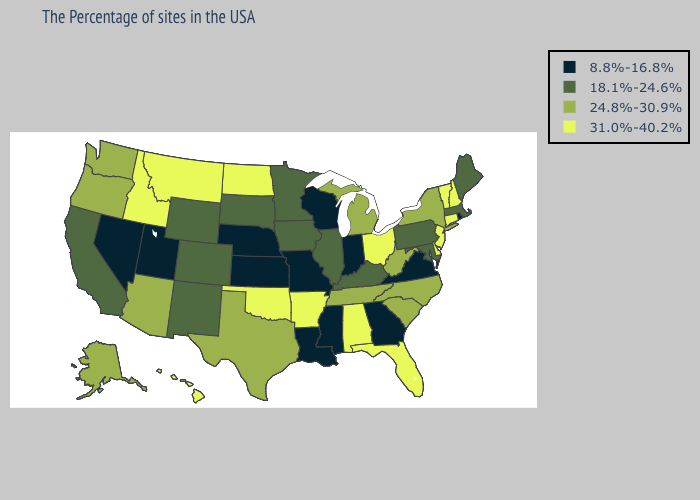What is the value of Oklahoma?
Concise answer only. 31.0%-40.2%. Does Iowa have the lowest value in the MidWest?
Be succinct. No. Name the states that have a value in the range 18.1%-24.6%?
Quick response, please. Maine, Massachusetts, Maryland, Pennsylvania, Kentucky, Illinois, Minnesota, Iowa, South Dakota, Wyoming, Colorado, New Mexico, California. Among the states that border Indiana , does Illinois have the highest value?
Concise answer only. No. What is the value of Michigan?
Short answer required. 24.8%-30.9%. Name the states that have a value in the range 24.8%-30.9%?
Give a very brief answer. New York, North Carolina, South Carolina, West Virginia, Michigan, Tennessee, Texas, Arizona, Washington, Oregon, Alaska. Name the states that have a value in the range 24.8%-30.9%?
Answer briefly. New York, North Carolina, South Carolina, West Virginia, Michigan, Tennessee, Texas, Arizona, Washington, Oregon, Alaska. Which states have the lowest value in the South?
Short answer required. Virginia, Georgia, Mississippi, Louisiana. Which states have the lowest value in the USA?
Short answer required. Rhode Island, Virginia, Georgia, Indiana, Wisconsin, Mississippi, Louisiana, Missouri, Kansas, Nebraska, Utah, Nevada. Does Pennsylvania have the highest value in the Northeast?
Answer briefly. No. What is the lowest value in the South?
Answer briefly. 8.8%-16.8%. Among the states that border Oklahoma , does Arkansas have the highest value?
Keep it brief. Yes. What is the value of Wisconsin?
Give a very brief answer. 8.8%-16.8%. Among the states that border Washington , does Idaho have the highest value?
Quick response, please. Yes. Among the states that border Louisiana , which have the lowest value?
Keep it brief. Mississippi. 